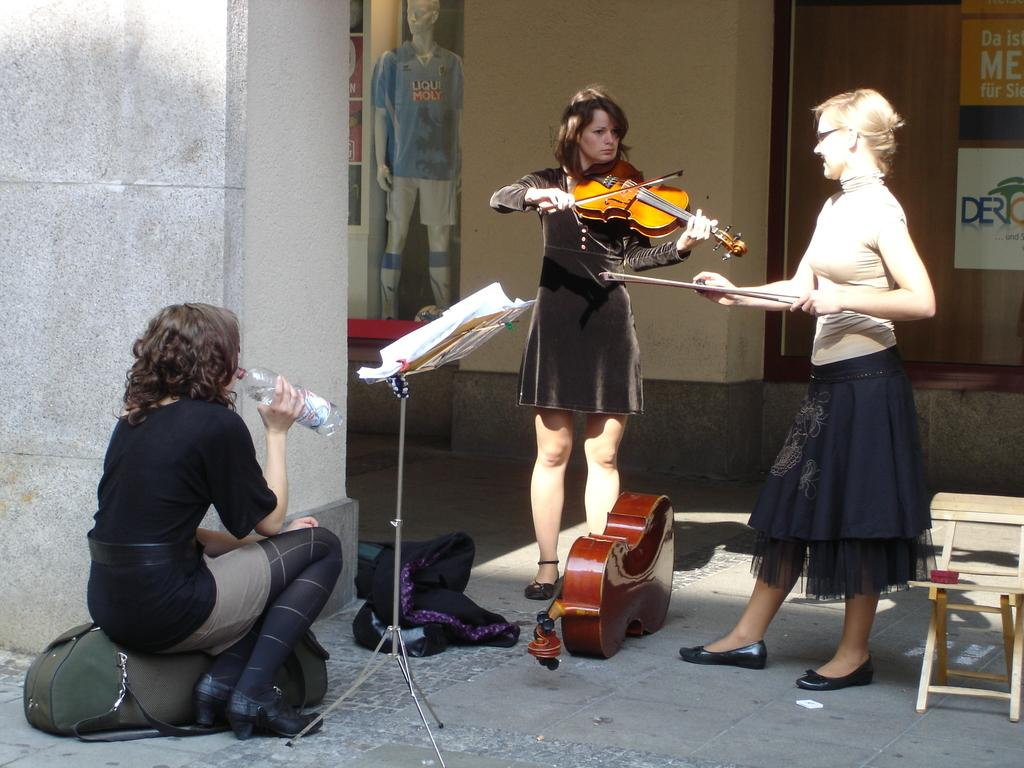How many people are present in the image? There are three people in the image. What are two of the people doing in the image? Two of the people are playing musical instruments. What is the third person doing in the image? The person sitting on the bag is holding a water bottle. What type of education does the mother in the image have? There is no mention of a mother or education in the image, so this information cannot be determined. 